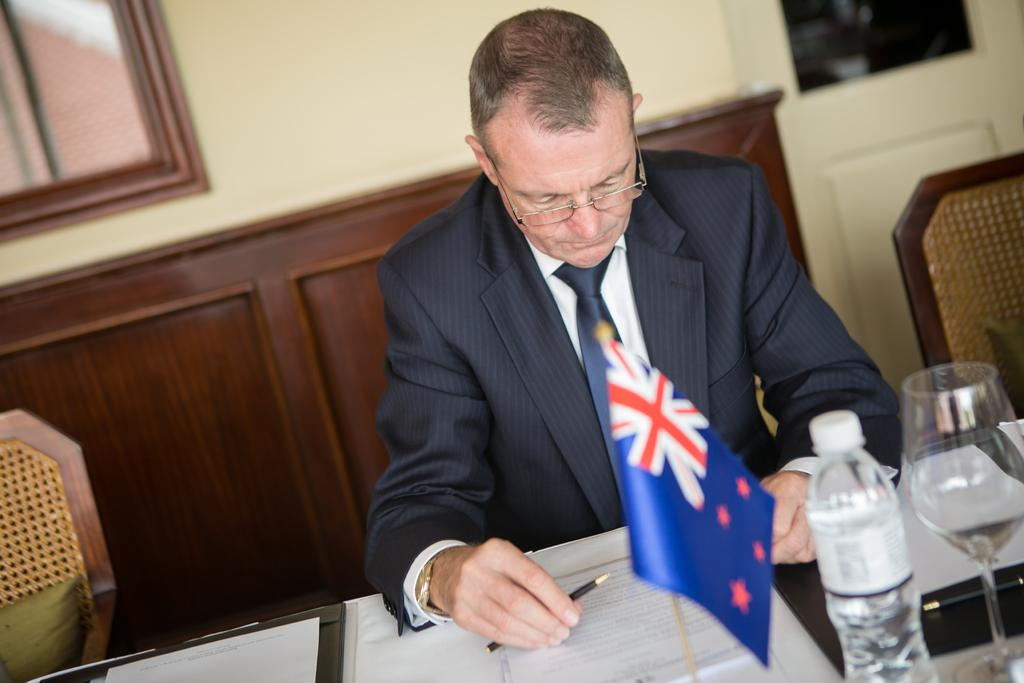What is the person in the image doing? The person is sitting and writing with a pencil on a paper. What objects are on the table in the image? There is a bottle, a glass, and a flag on the table. What can be seen in the background of the image? There is a wall and a cupboard in the background. How many trees are visible in the image? There are no trees visible in the image. Is the queen present in the image? There is no queen present in the image. 